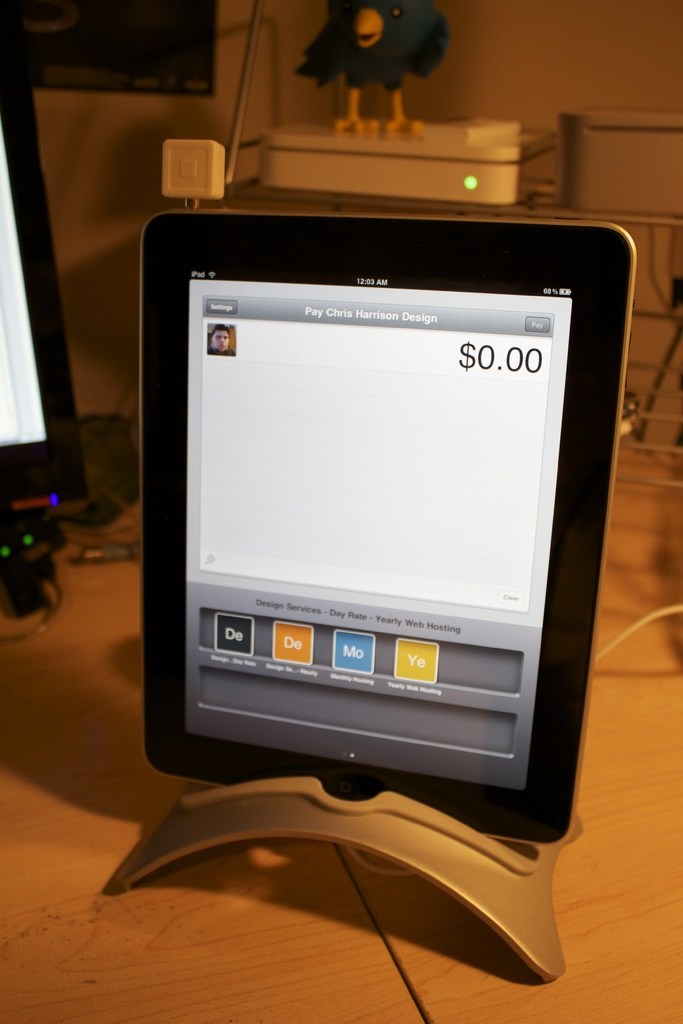Does the image indicate if payment has been made? The screen shows a payment sum of $0.00, indicating that no payment has been made yet, or the service is offered at no cost. 